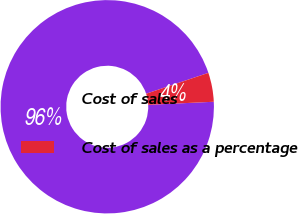<chart> <loc_0><loc_0><loc_500><loc_500><pie_chart><fcel>Cost of sales<fcel>Cost of sales as a percentage<nl><fcel>95.6%<fcel>4.4%<nl></chart> 